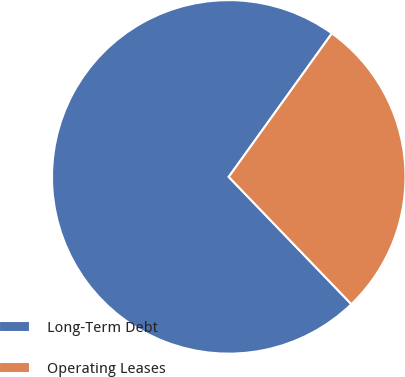Convert chart. <chart><loc_0><loc_0><loc_500><loc_500><pie_chart><fcel>Long-Term Debt<fcel>Operating Leases<nl><fcel>72.12%<fcel>27.88%<nl></chart> 